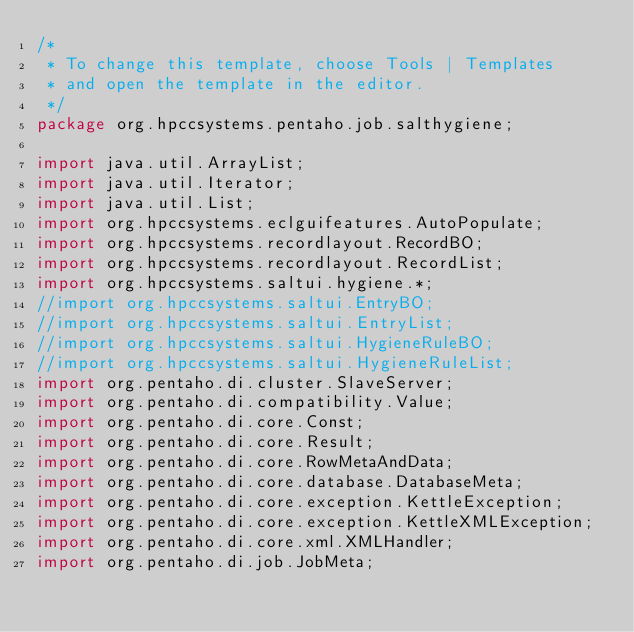Convert code to text. <code><loc_0><loc_0><loc_500><loc_500><_Java_>/*
 * To change this template, choose Tools | Templates
 * and open the template in the editor.
 */
package org.hpccsystems.pentaho.job.salthygiene;

import java.util.ArrayList;
import java.util.Iterator;
import java.util.List;
import org.hpccsystems.eclguifeatures.AutoPopulate;
import org.hpccsystems.recordlayout.RecordBO;
import org.hpccsystems.recordlayout.RecordList;
import org.hpccsystems.saltui.hygiene.*;
//import org.hpccsystems.saltui.EntryBO;
//import org.hpccsystems.saltui.EntryList;
//import org.hpccsystems.saltui.HygieneRuleBO;
//import org.hpccsystems.saltui.HygieneRuleList;
import org.pentaho.di.cluster.SlaveServer;
import org.pentaho.di.compatibility.Value;
import org.pentaho.di.core.Const;
import org.pentaho.di.core.Result;
import org.pentaho.di.core.RowMetaAndData;
import org.pentaho.di.core.database.DatabaseMeta;
import org.pentaho.di.core.exception.KettleException;
import org.pentaho.di.core.exception.KettleXMLException;
import org.pentaho.di.core.xml.XMLHandler;
import org.pentaho.di.job.JobMeta;</code> 